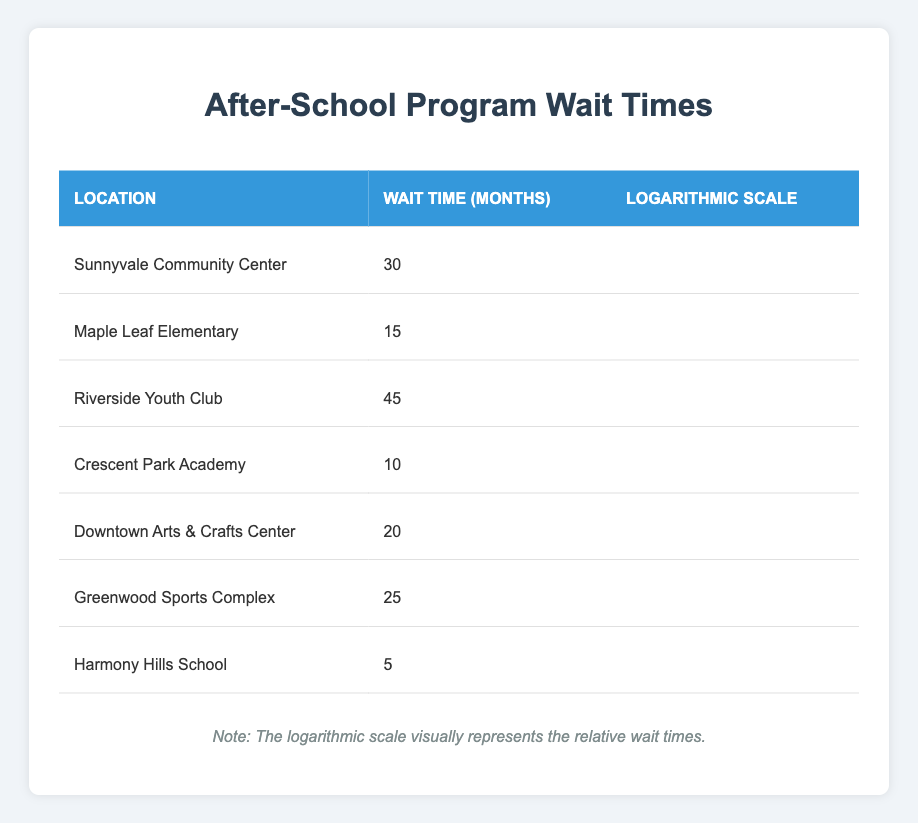What is the wait time at Crescent Park Academy? The table lists the wait time for Crescent Park Academy as 10 months. This fact can be directly retrieved from the relevant row under the "Wait Time (Months)" column.
Answer: 10 Which location has the longest wait time? Looking through the "Wait Time (Months)" column, Riverside Youth Club has the highest value at 45 months, which indicates it has the longest wait time.
Answer: Riverside Youth Club What is the average wait time for all locations? To find the average, sum the wait times: 30 + 15 + 45 + 10 + 20 + 25 + 5 = 150 months. There are 7 locations, so the average wait time is 150 / 7 ≈ 21.43 months.
Answer: 21.43 Is the wait time at Harmony Hills School less than 10 months? The wait time at Harmony Hills School is listed as 5 months, which is indeed less than 10 months. Thus, the statement is true.
Answer: Yes What is the difference in wait time between the location with the shortest and longest wait times? The shortest wait time is at Harmony Hills School, which is 5 months, and the longest is at Riverside Youth Club, which is 45 months. The difference is 45 - 5 = 40 months.
Answer: 40 How many locations have a wait time of less than 20 months? By examining the wait times, Crescent Park Academy (10 months), Maple Leaf Elementary (15 months), and Harmony Hills School (5 months) all have wait times under 20 months. This gives a total of 3 locations.
Answer: 3 Are there any locations with a wait time of exactly 25 months? By checking the table, Greenwood Sports Complex has a wait time of exactly 25 months.
Answer: Yes What is the combined wait time of all locations except Downtown Arts & Crafts Center? The wait times for the other locations are 30, 15, 45, 10, 25, and 5 months. The combined wait time is 30 + 15 + 45 + 10 + 25 + 5 = 130 months.
Answer: 130 